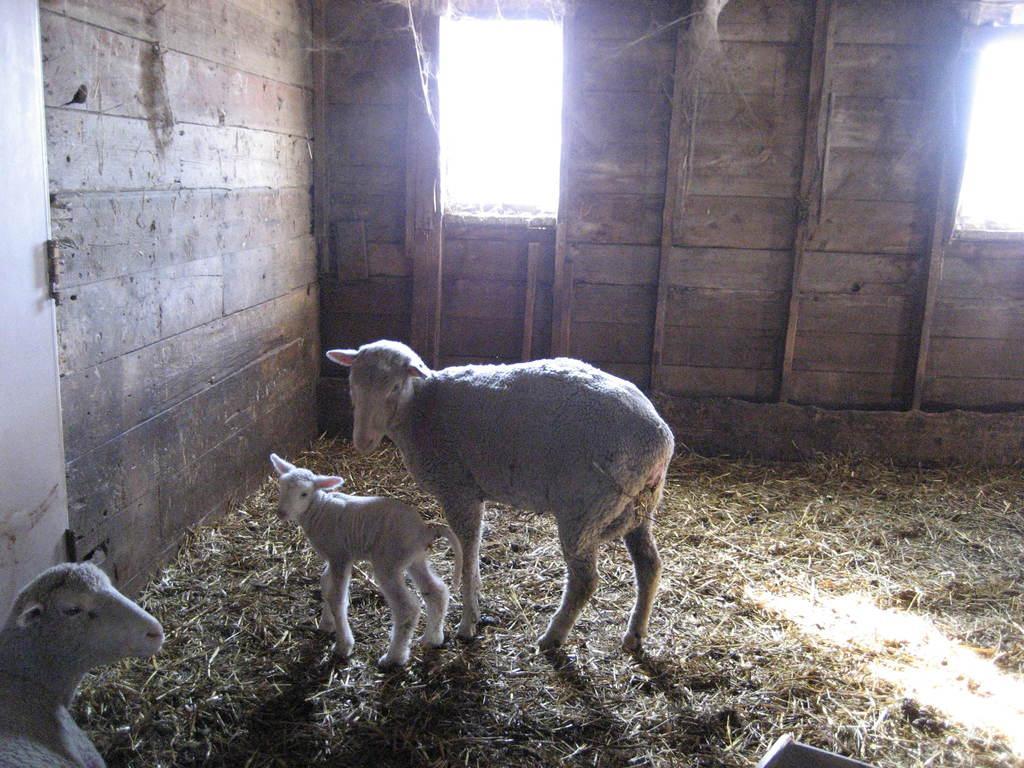Can you describe this image briefly? In this image there are three sheeps inside a shed , and there is grass. 